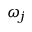Convert formula to latex. <formula><loc_0><loc_0><loc_500><loc_500>\omega _ { j }</formula> 